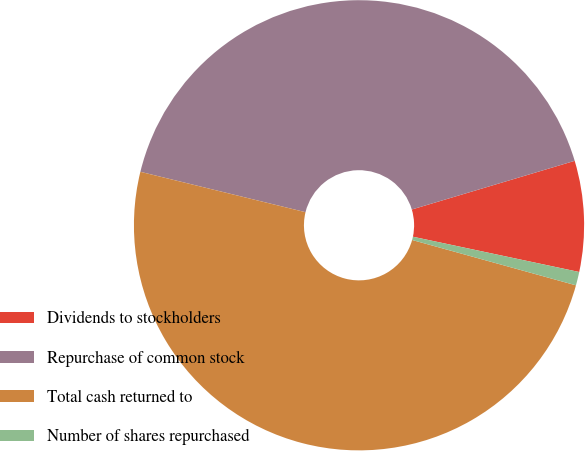Convert chart. <chart><loc_0><loc_0><loc_500><loc_500><pie_chart><fcel>Dividends to stockholders<fcel>Repurchase of common stock<fcel>Total cash returned to<fcel>Number of shares repurchased<nl><fcel>7.95%<fcel>41.56%<fcel>49.52%<fcel>0.97%<nl></chart> 